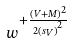<formula> <loc_0><loc_0><loc_500><loc_500>w ^ { + \frac { ( V + M ) ^ { 2 } } { 2 { ( s _ { V } ) } ^ { 2 } } }</formula> 